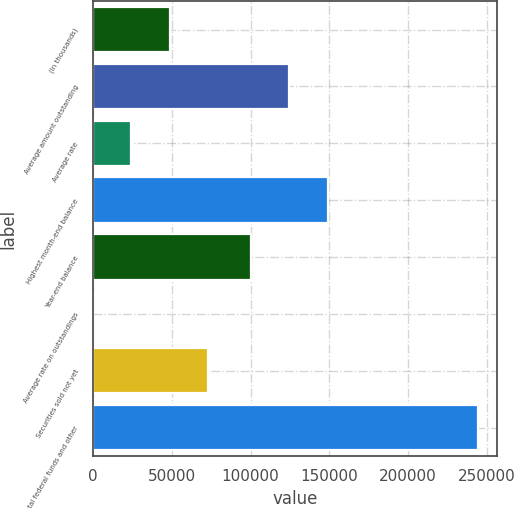<chart> <loc_0><loc_0><loc_500><loc_500><bar_chart><fcel>(In thousands)<fcel>Average amount outstanding<fcel>Average rate<fcel>Highest month-end balance<fcel>Year-end balance<fcel>Average rate on outstandings<fcel>Securities sold not yet<fcel>Total federal funds and other<nl><fcel>48844.7<fcel>124615<fcel>24422.4<fcel>149038<fcel>100193<fcel>0.15<fcel>73267<fcel>244223<nl></chart> 